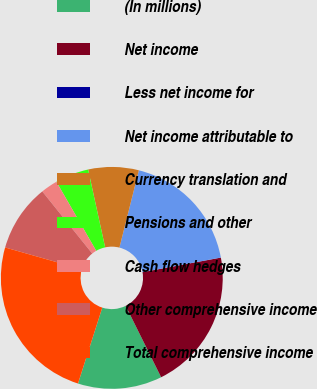<chart> <loc_0><loc_0><loc_500><loc_500><pie_chart><fcel>(In millions)<fcel>Net income<fcel>Less net income for<fcel>Net income attributable to<fcel>Currency translation and<fcel>Pensions and other<fcel>Cash flow hedges<fcel>Other comprehensive income<fcel>Total comprehensive income<nl><fcel>12.26%<fcel>20.59%<fcel>0.01%<fcel>18.14%<fcel>7.35%<fcel>4.9%<fcel>2.45%<fcel>9.8%<fcel>24.49%<nl></chart> 